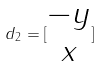Convert formula to latex. <formula><loc_0><loc_0><loc_500><loc_500>d _ { 2 } = [ \begin{matrix} - y \\ x \\ \end{matrix} ]</formula> 